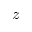Convert formula to latex. <formula><loc_0><loc_0><loc_500><loc_500>z</formula> 